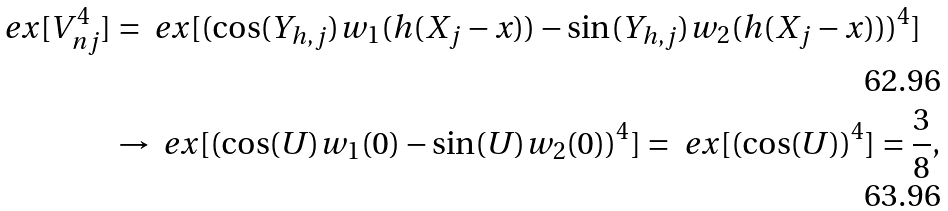<formula> <loc_0><loc_0><loc_500><loc_500>\ e x [ V _ { n j } ^ { 4 } ] & = \ e x [ ( \cos ( Y _ { h , j } ) w _ { 1 } ( h ( X _ { j } - x ) ) - \sin ( Y _ { h , j } ) w _ { 2 } ( h ( X _ { j } - x ) ) ) ^ { 4 } ] \\ & \rightarrow \ e x [ ( \cos ( U ) w _ { 1 } ( 0 ) - \sin ( U ) w _ { 2 } ( 0 ) ) ^ { 4 } ] = \ e x [ ( \cos ( U ) ) ^ { 4 } ] = \frac { 3 } { 8 } ,</formula> 